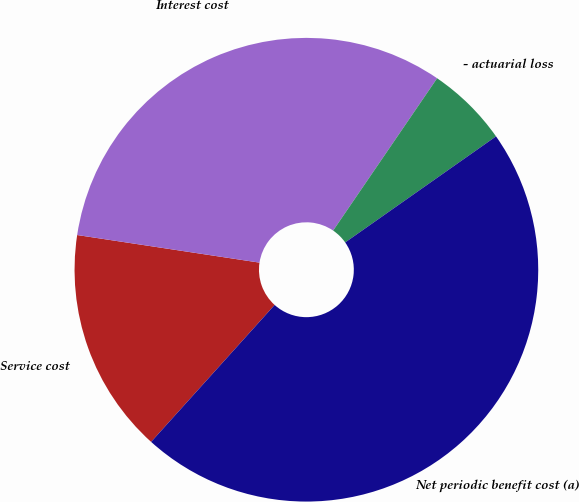Convert chart. <chart><loc_0><loc_0><loc_500><loc_500><pie_chart><fcel>Service cost<fcel>Interest cost<fcel>- actuarial loss<fcel>Net periodic benefit cost (a)<nl><fcel>15.71%<fcel>32.14%<fcel>5.71%<fcel>46.43%<nl></chart> 